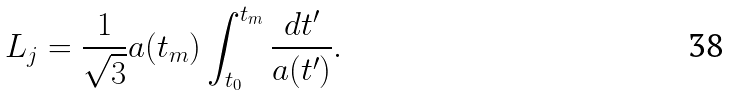Convert formula to latex. <formula><loc_0><loc_0><loc_500><loc_500>L _ { j } = \frac { 1 } { \sqrt { 3 } } a ( t _ { m } ) \int _ { t _ { 0 } } ^ { t _ { m } } \frac { d t ^ { \prime } } { a ( t ^ { \prime } ) } .</formula> 